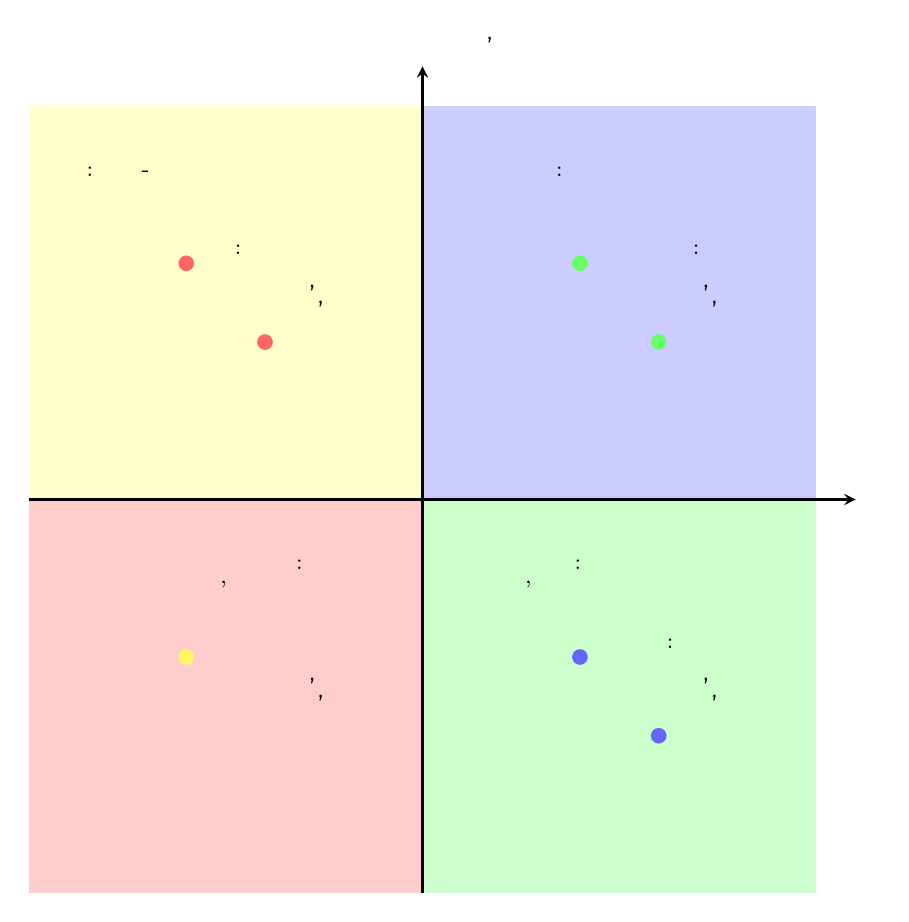What types of activities fall into the "High Time Investment, High Health Benefits" quadrant? The diagram lists "Running" and "Meal Prepping" in this quadrant, indicating these activities require a significant amount of time and also offer substantial health benefits.
Answer: Running, Meal Prepping How many activities are represented in the "Low Time Investment, Low Health Benefits" quadrant? There are two activities listed in this quadrant: "Taking Short Walks" and "Skimping on Meals," which leads to the conclusion that there are a total of two activities in this category.
Answer: 2 What health benefit is associated with "Eating More Fruits and Vegetables"? According to the diagram, this activity is noted for its high health benefits, particularly in increasing the intake of essential nutrients.
Answer: High Which activity has a high time investment but low health benefits? The diagram clearly indicates "Home-Cooked Recipes with High Calories" in the relevant quadrant, illustrating that while this activity takes time, it does not provide significant health benefits.
Answer: Home-Cooked Recipes with High Calories In which quadrant would "Taking the Stairs" be classified? The activity "Taking the Stairs" is found in the "Low Time Investment, High Health Benefits" quadrant, suggesting it’s an efficient way to enhance physical activity with minimal time commitment.
Answer: Low Time Investment, High Health Benefits What is the primary characteristic of the "High Time Investment, Low Health Benefits" quadrant? This quadrant specifically includes activities that require a lot of time but do not yield meaningful health improvements, as demonstrated by the listed activities.
Answer: High Time Investment, Low Health Benefits Which two activities are listed with "Low Time Investment, High Health Benefits"? The activities of "Taking the Stairs" and "Eating More Fruits and Vegetables" are both identified in this quadrant, highlighting options that are both quick to undertake and beneficial for health.
Answer: Taking the Stairs, Eating More Fruits and Vegetables What quadrant contains activities associated with limited health benefits? The "Low Time Investment, Low Health Benefits" quadrant includes activities that generally do not promote significant health improvements, as indicated by its criteria.
Answer: Low Time Investment, Low Health Benefits 